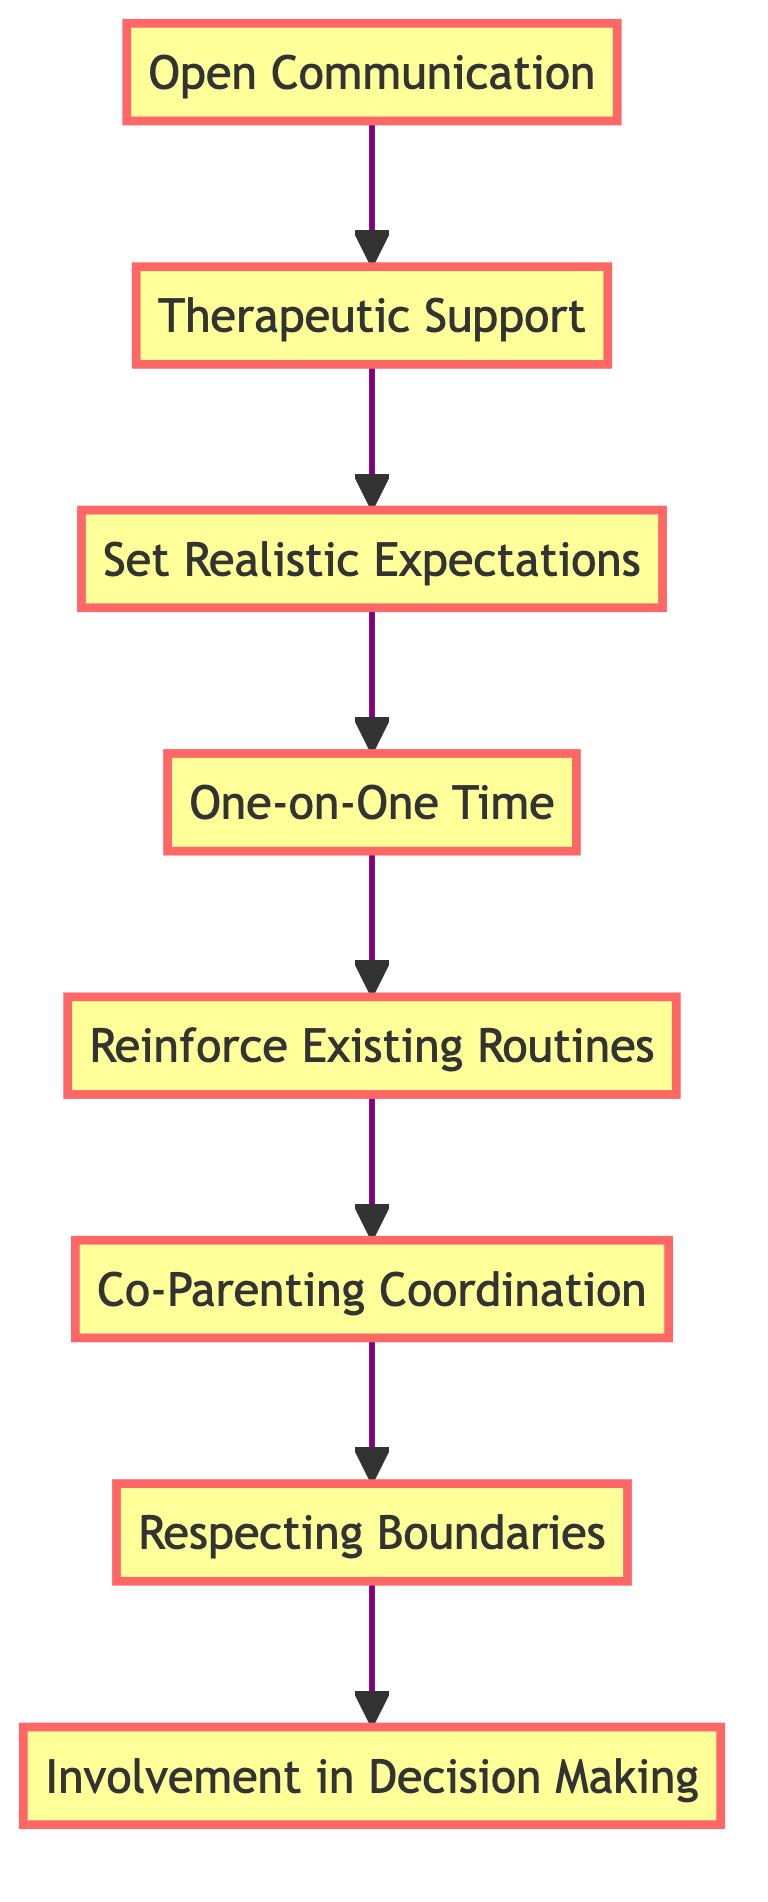What is the first step in helping children adjust to a new stepparent? The first node in the flowchart is "Open Communication," which indicates that this is the initial step suggested for helping children adjust.
Answer: Open Communication How many total steps are indicated in the diagram? The diagram contains eight distinct nodes, which represent the steps involved in the process.
Answer: Eight What is the last step mentioned in the flowchart? The final node in the flowchart is "Involvement in Decision Making," making it the last step in the instructional process.
Answer: Involvement in Decision Making Which step follows "Reinforce Existing Routines"? The node that comes after "Reinforce Existing Routines" is "Co-Parenting Coordination," indicating the next recommended action.
Answer: Co-Parenting Coordination What two steps are directly connected to "Open Communication"? "Open Communication" leads directly to "Therapeutic Support" and is the starting point of the flowchart, showing its initial position.
Answer: Therapeutic Support and One-on-One Time How are the steps organized in this diagram? The steps are organized in a top-to-bottom flow structure, starting from "Open Communication" at the top and ending with "Involvement in Decision Making" at the bottom, emphasizing sequential guidance.
Answer: Top to bottom What does "Respecting Boundaries" connect to in the flowchart? "Respecting Boundaries" is positioned after "Co-Parenting Coordination," as indicated by the flow from one node to the next, illustrating its role in the sequence.
Answer: Co-Parenting Coordination Which steps are highlighted in the diagram? All steps in the diagram are highlighted, which signifies their importance in the instructional flow regarding children adjusting to a new stepparent.
Answer: All steps What is the relationship between "One-on-One Time" and "Set Realistic Expectations"? "One-on-One Time" follows "Set Realistic Expectations," showing that one should take place after the other, establishing a sequential relationship related to the adjustment process.
Answer: Sequenced steps 